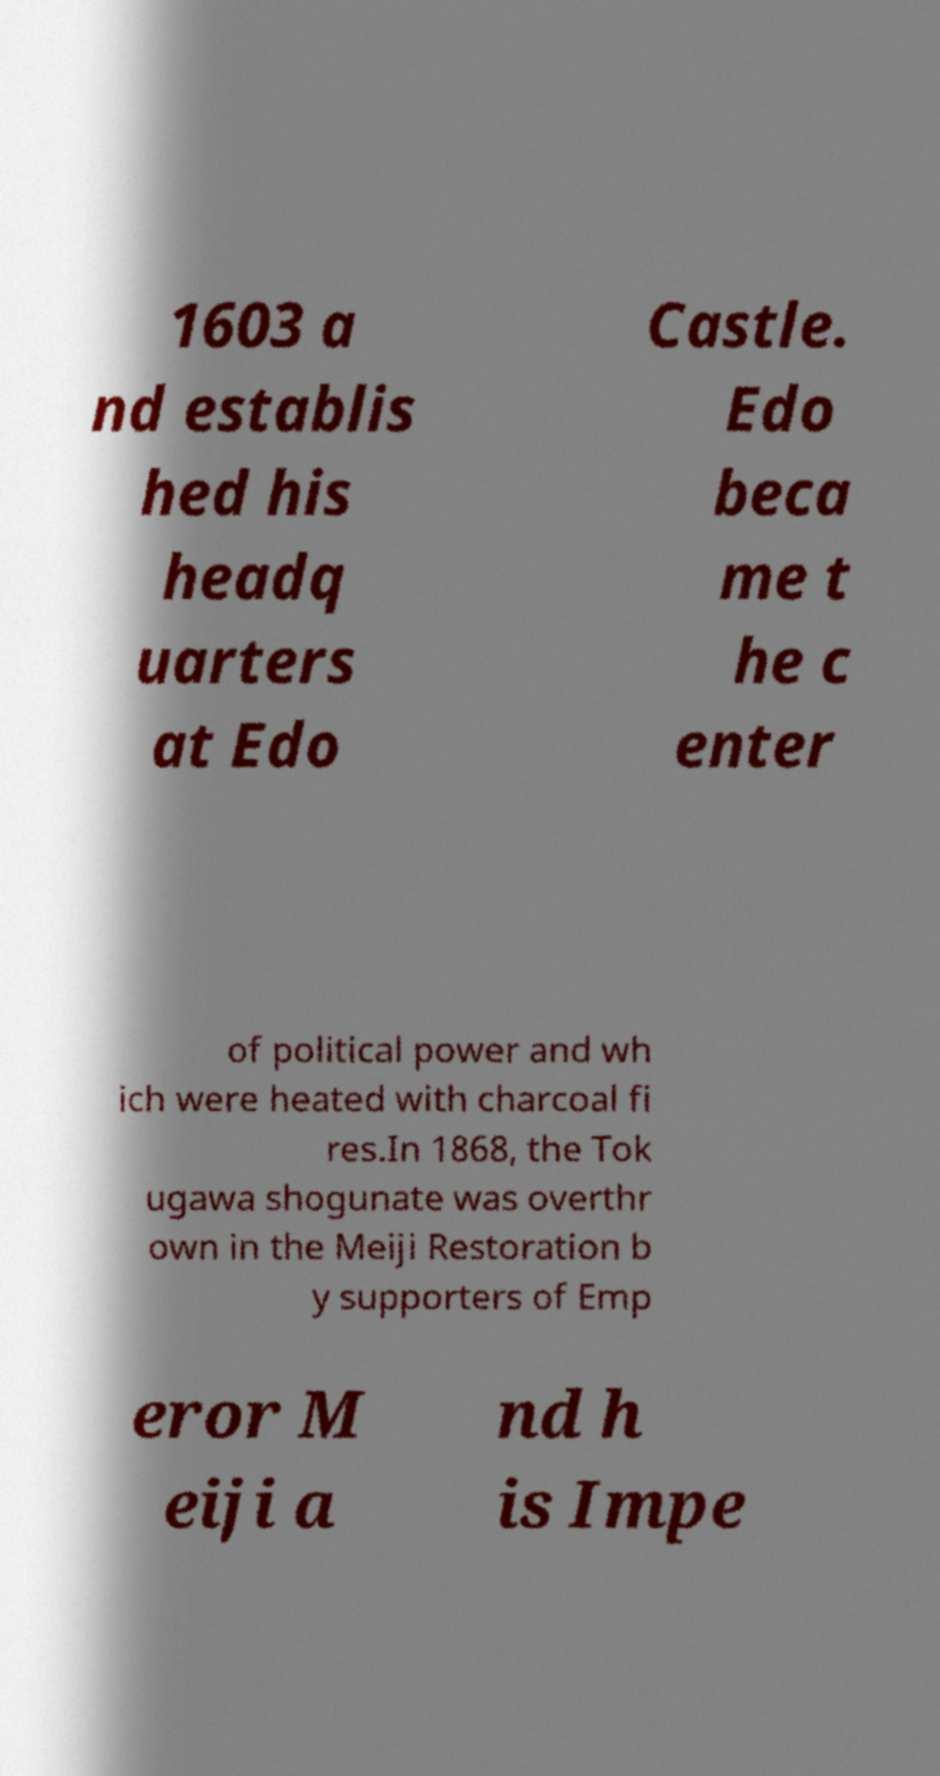I need the written content from this picture converted into text. Can you do that? 1603 a nd establis hed his headq uarters at Edo Castle. Edo beca me t he c enter of political power and wh ich were heated with charcoal fi res.In 1868, the Tok ugawa shogunate was overthr own in the Meiji Restoration b y supporters of Emp eror M eiji a nd h is Impe 